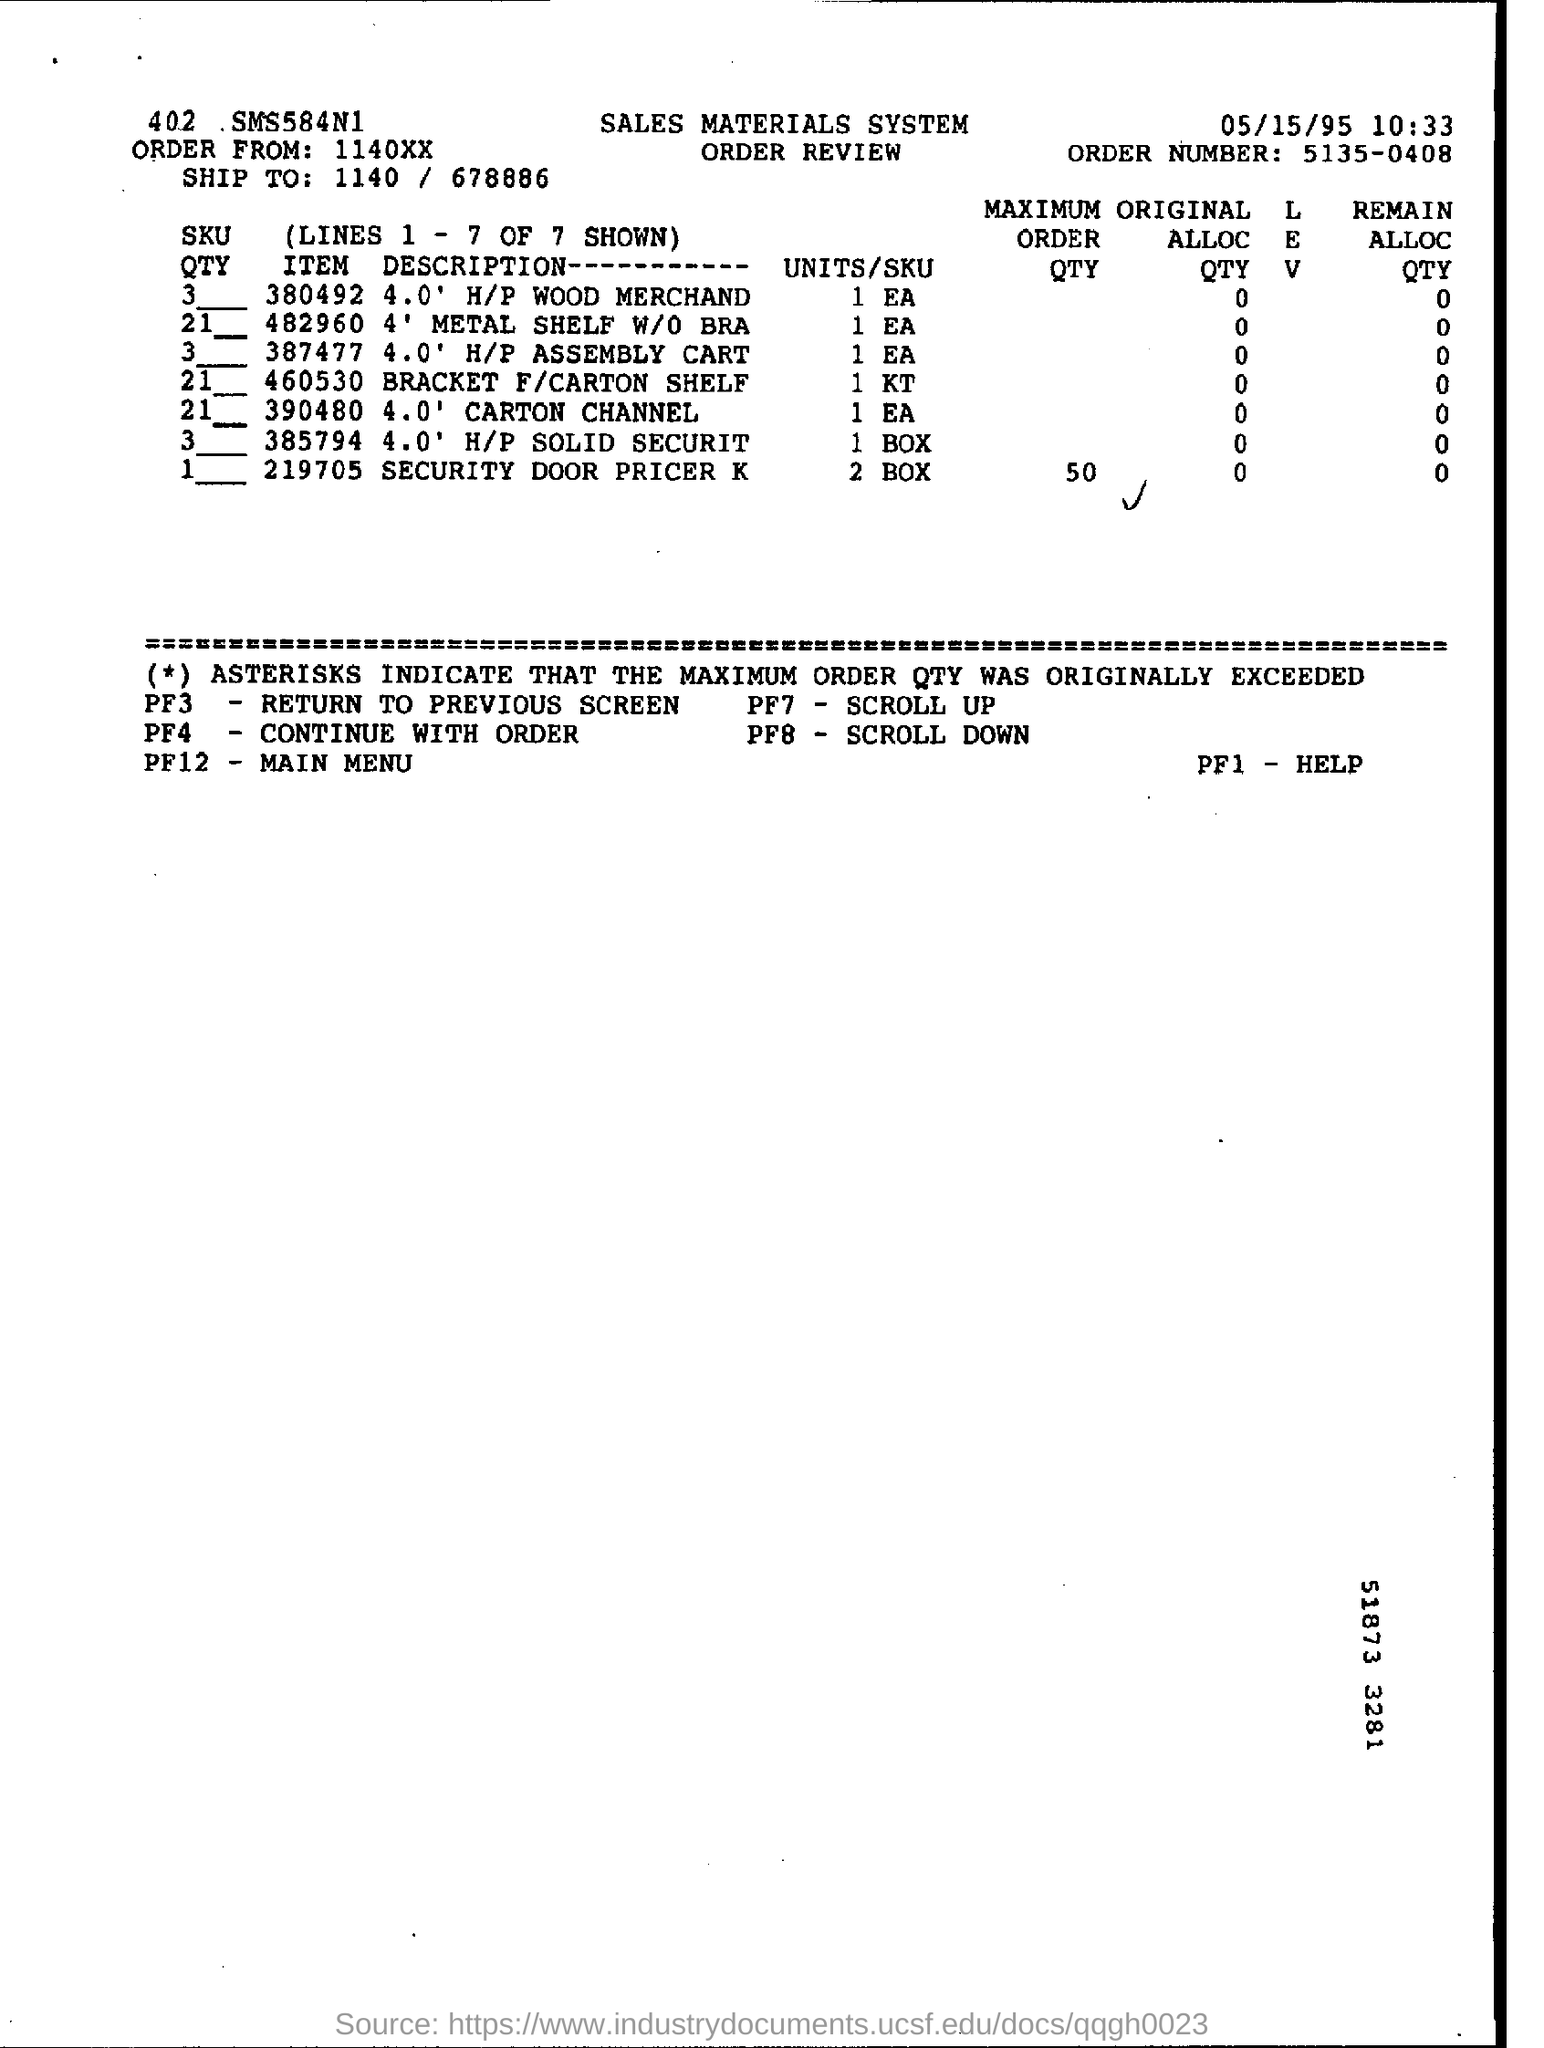What is the order no. mentioned ?
Provide a short and direct response. 5135-0408. What is the date mentioned in the given page ?
Offer a terse response. 05/15/95. What is the order from number mentioned ?
Provide a short and direct response. 1140xx. What is the time mentioned in the given form ?
Your answer should be very brief. 10:33. 